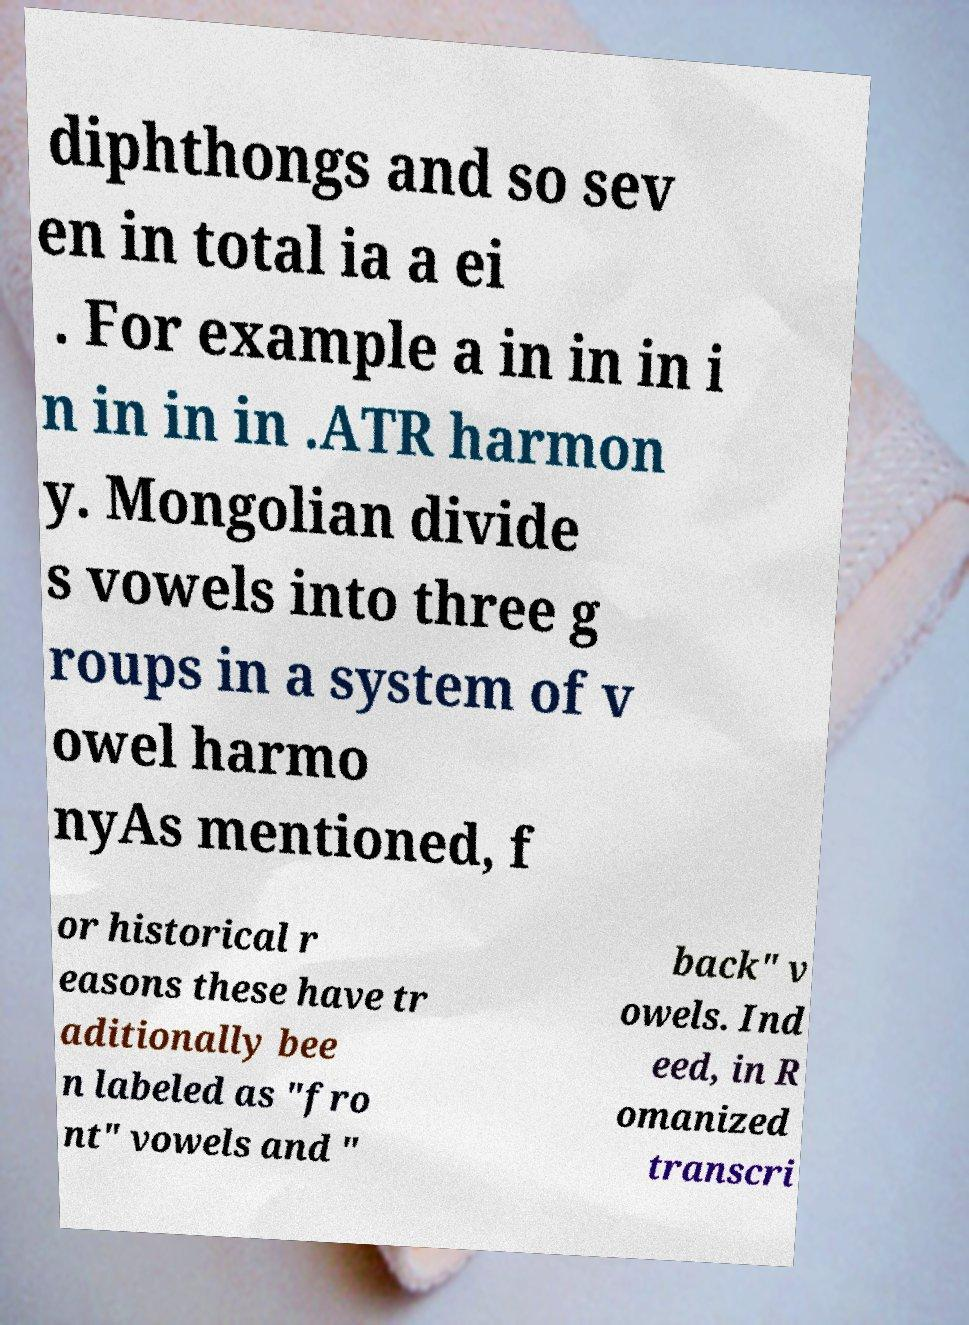Please identify and transcribe the text found in this image. diphthongs and so sev en in total ia a ei . For example a in in in i n in in in .ATR harmon y. Mongolian divide s vowels into three g roups in a system of v owel harmo nyAs mentioned, f or historical r easons these have tr aditionally bee n labeled as "fro nt" vowels and " back" v owels. Ind eed, in R omanized transcri 